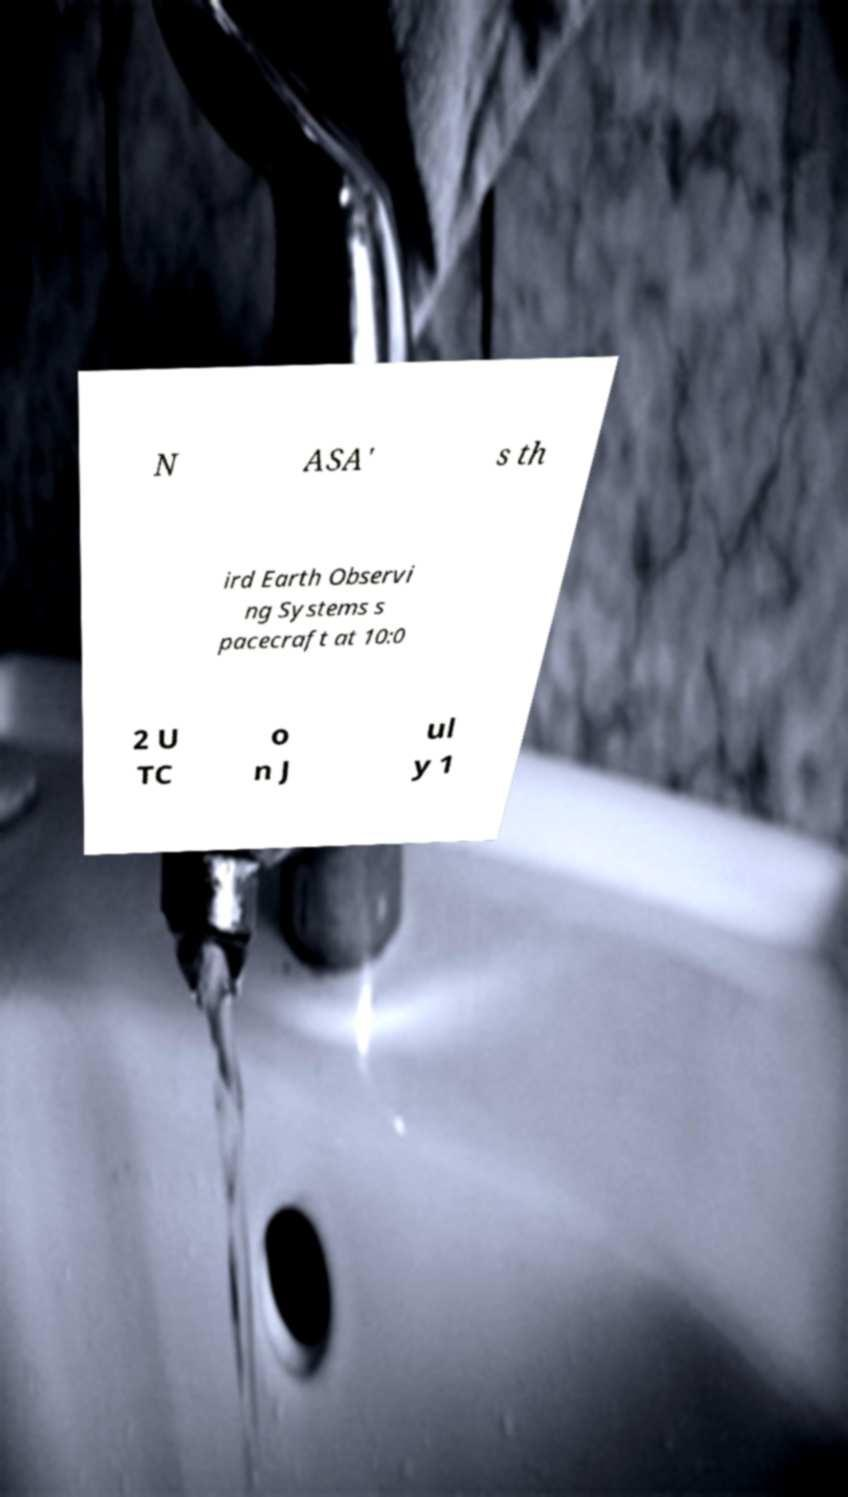Could you assist in decoding the text presented in this image and type it out clearly? N ASA' s th ird Earth Observi ng Systems s pacecraft at 10:0 2 U TC o n J ul y 1 